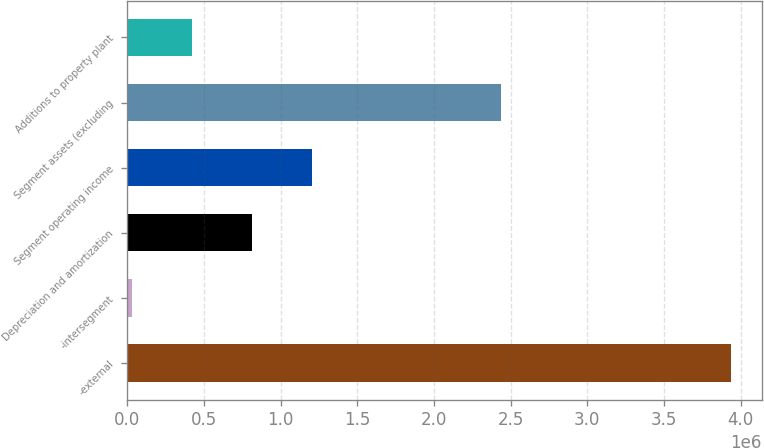Convert chart. <chart><loc_0><loc_0><loc_500><loc_500><bar_chart><fcel>-external<fcel>-intersegment<fcel>Depreciation and amortization<fcel>Segment operating income<fcel>Segment assets (excluding<fcel>Additions to property plant<nl><fcel>3.93979e+06<fcel>28763<fcel>810968<fcel>1.20207e+06<fcel>2.43741e+06<fcel>419865<nl></chart> 